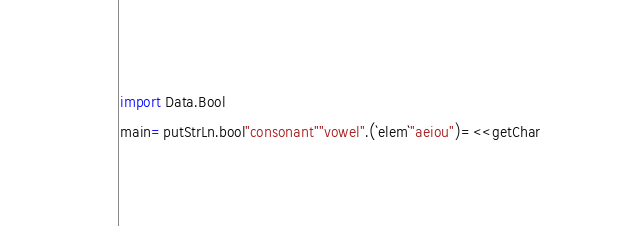Convert code to text. <code><loc_0><loc_0><loc_500><loc_500><_Haskell_>import Data.Bool
main=putStrLn.bool"consonant""vowel".(`elem`"aeiou")=<<getChar</code> 